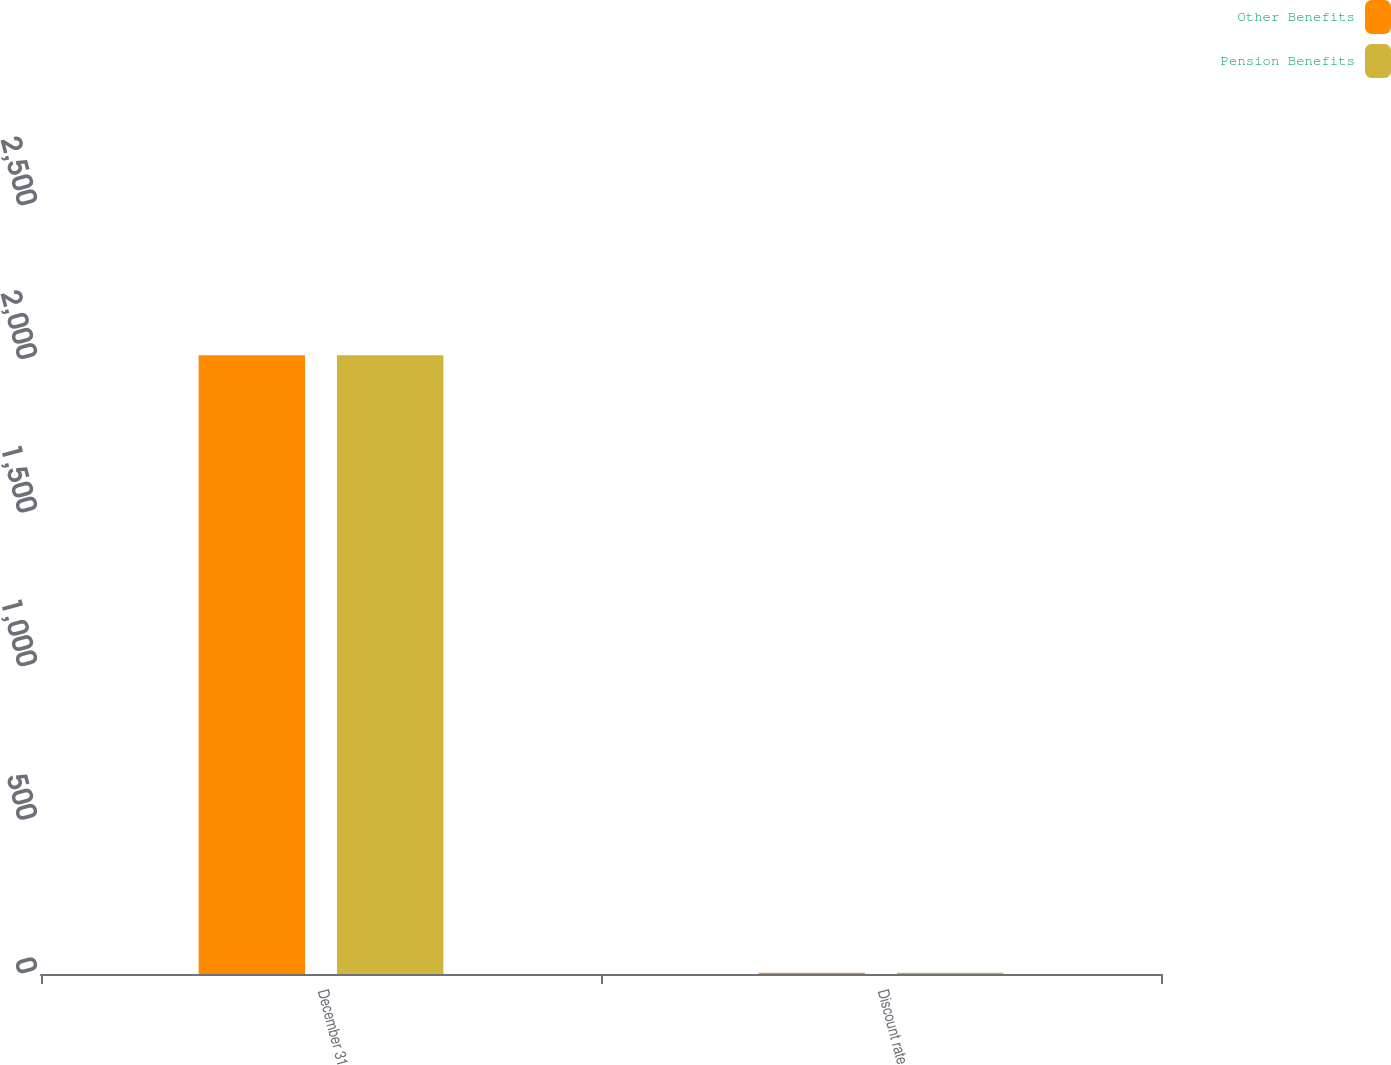Convert chart. <chart><loc_0><loc_0><loc_500><loc_500><stacked_bar_chart><ecel><fcel>December 31<fcel>Discount rate<nl><fcel>Other Benefits<fcel>2014<fcel>3.7<nl><fcel>Pension Benefits<fcel>2014<fcel>3.7<nl></chart> 